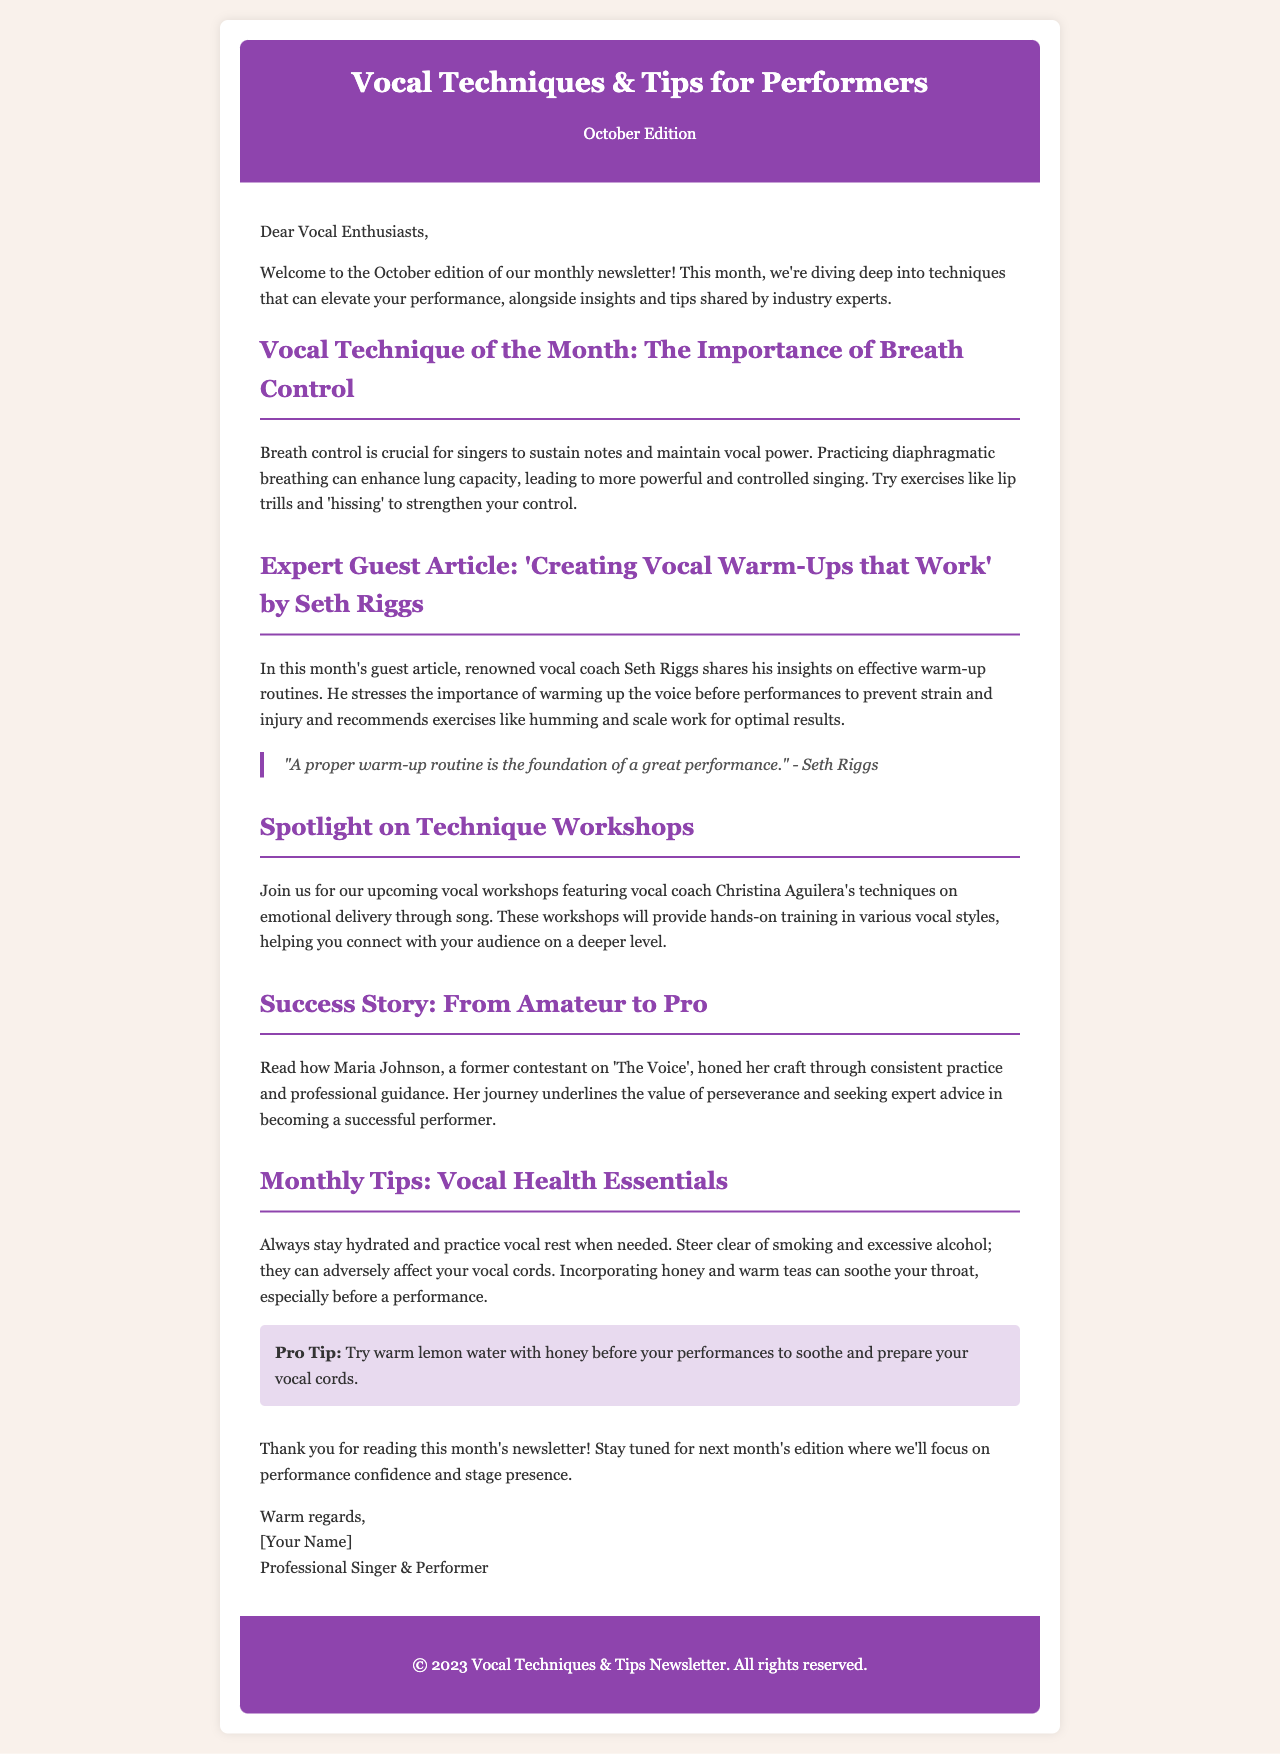What is the title of this newsletter? The title of the newsletter is prominently displayed in the header section.
Answer: Vocal Techniques & Tips for Performers Who is the guest article by? The guest article title indicates the author's name for this month's feature.
Answer: Seth Riggs What is the main vocal technique discussed this month? The content section outlines the focus of this month's vocal technique.
Answer: Breath Control What is the pro tip mentioned in the monthly tips section? The pro tip provides a specific recommendation to enhance vocal performance.
Answer: Warm lemon water with honey Which singer's techniques are featured in the upcoming workshops? The content specifies which well-known artist's techniques will be highlighted.
Answer: Christina Aguilera What success story is shared in the newsletter? The success story section features a particular individual to illustrate a journey.
Answer: Maria Johnson What color is used for the header background? The header section's background color is described in the style section of the document.
Answer: Purple When will the next edition focus on? The closing section mentions the topic of the next month's newsletter edition.
Answer: Performance confidence and stage presence 